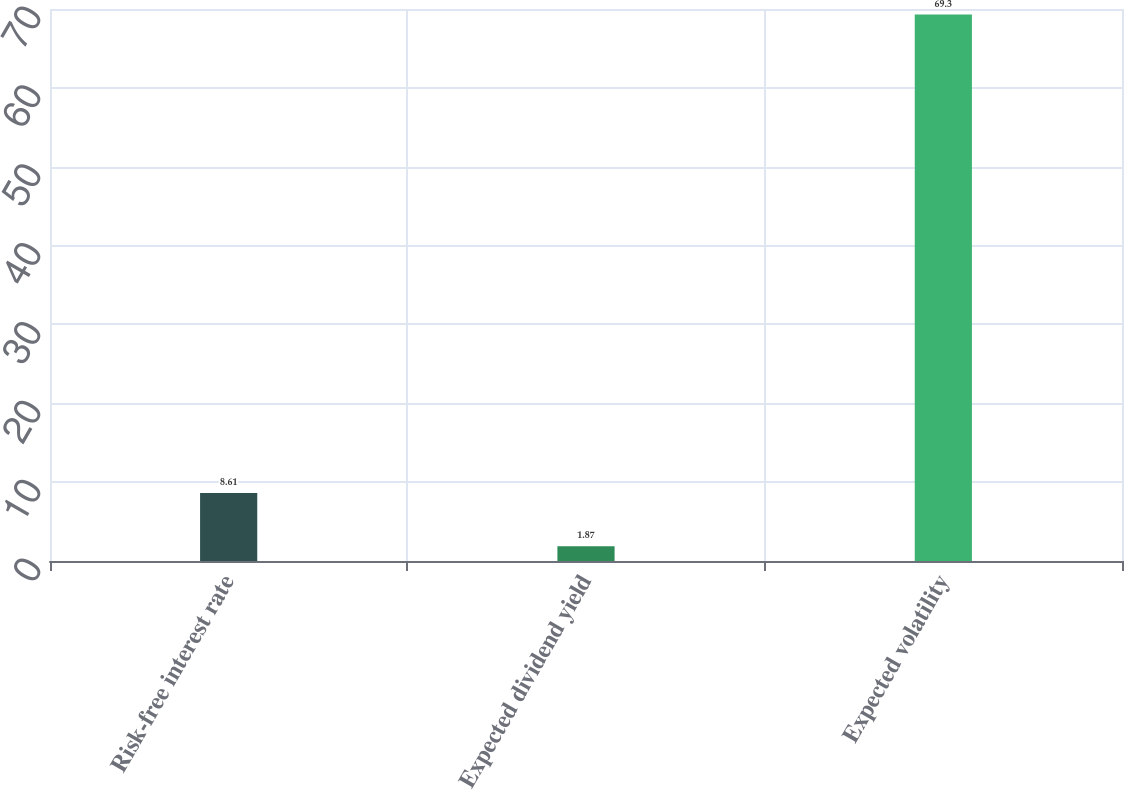<chart> <loc_0><loc_0><loc_500><loc_500><bar_chart><fcel>Risk-free interest rate<fcel>Expected dividend yield<fcel>Expected volatility<nl><fcel>8.61<fcel>1.87<fcel>69.3<nl></chart> 